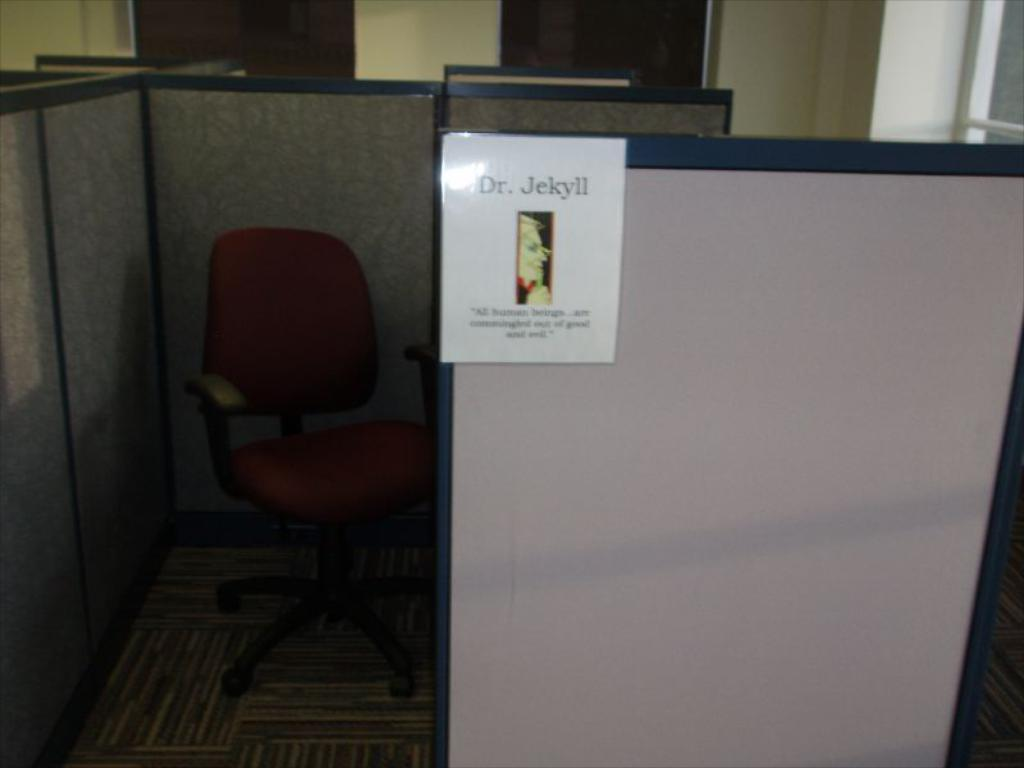<image>
Create a compact narrative representing the image presented. Office desk cubicle with a poster sign that says Dr. Jekyll. 